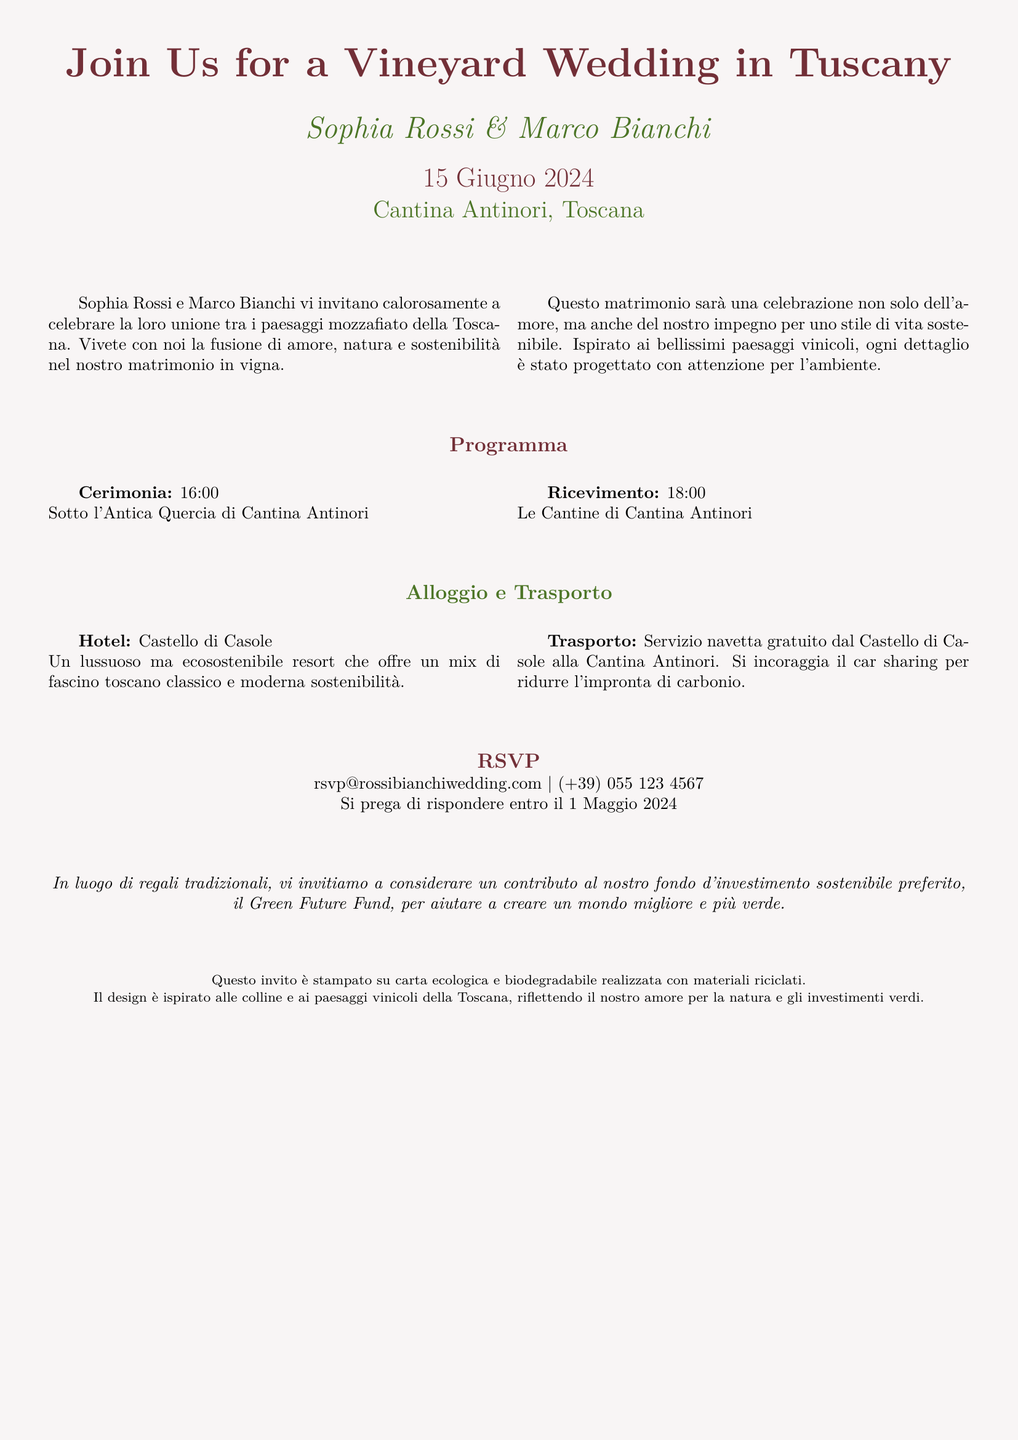Qual è la data del matrimonio? La data del matrimonio è specificata nel documento come il 15 Giugno 2024.
Answer: 15 Giugno 2024 Dove si svolgerà la cerimonia? La cerimonia si svolgerà sotto l'Antica Quercia di Cantina Antinori, come indicato nel programma.
Answer: Cantina Antinori Qual è il nome della sposa? Il documento menziona Sophia Rossi come la sposa.
Answer: Sophia Rossi Qual è il nome dello sposo? Marco Bianchi è il nome dello sposo menzionato nel documento.
Answer: Marco Bianchi Qual è il nome del resort per l'alloggio? Il documento indica Castello di Casole come hotel per l'alloggio.
Answer: Castello di Casole Qual è l’impegno del matrimonio in termini di sostenibilità? L'invito sottolinea che il matrimonio è dedicato a uno stile di vita sostenibile e aiuta a raccogliere fondi per un investimento ecologico.
Answer: Sostenibilità Qual è il termine per la conferma della presenza? Il documento specifica di rispondere entro il 1 Maggio 2024.
Answer: 1 Maggio 2024 Quale carta è stata utilizzata per stampare l'invito? L'invito è stampato su carta ecologica e biodegradabile fatta da materiali riciclati.
Answer: Carta ecologica e biodegradabile Cosa si incoraggia in termini di trasporto? Si incoraggia il car sharing per ridurre l'impronta di carbonio, come indicato nelle informazioni sul trasporto.
Answer: Car sharing 